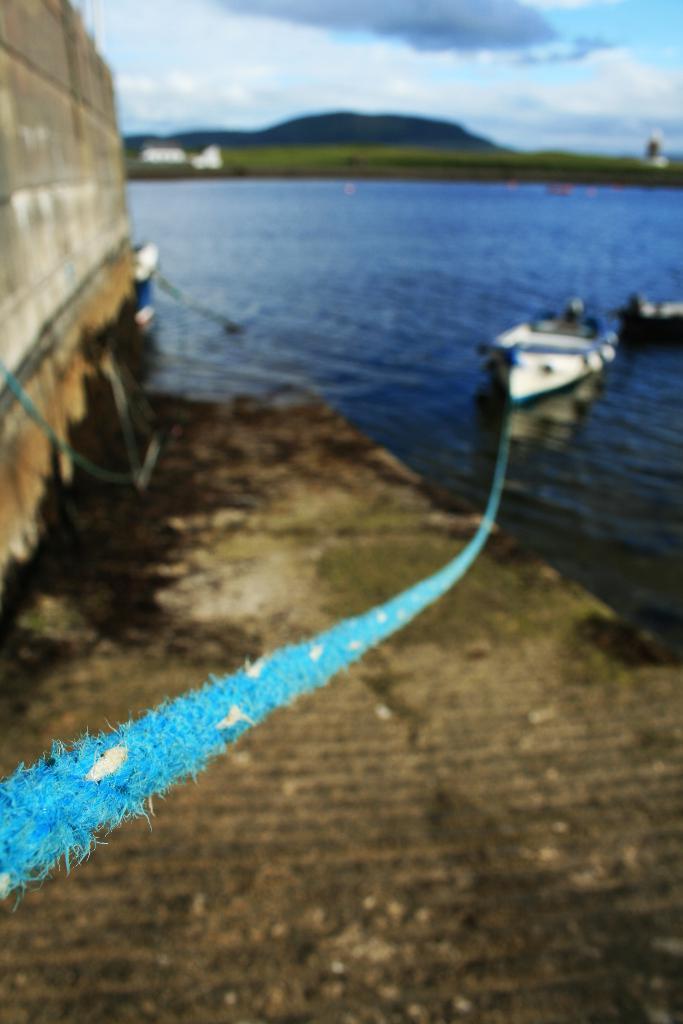Describe this image in one or two sentences. In front of the picture, we see the blue color rope is tied to the boat. Here, we see the boats are sailing on the water. This water might be in the pond. At the bottom, we see the ground. On the left side, we see a wall. In the background, we see the grass and the hills. At the top, we see the sky and the clouds. This picture is blurred. 